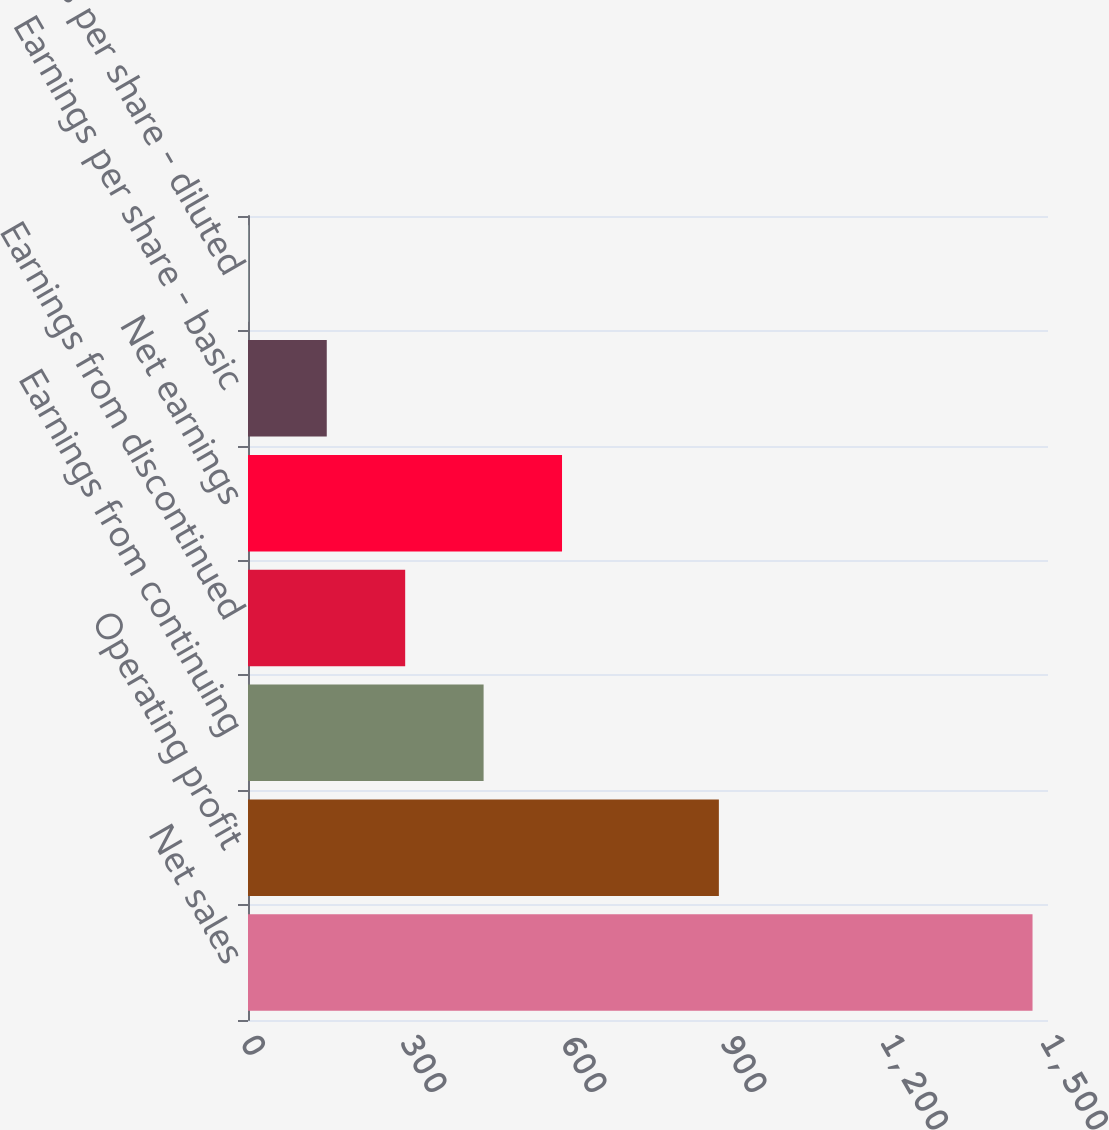<chart> <loc_0><loc_0><loc_500><loc_500><bar_chart><fcel>Net sales<fcel>Operating profit<fcel>Earnings from continuing<fcel>Earnings from discontinued<fcel>Net earnings<fcel>Earnings per share - basic<fcel>Earnings per share - diluted<nl><fcel>1471<fcel>882.88<fcel>441.76<fcel>294.72<fcel>588.8<fcel>147.68<fcel>0.64<nl></chart> 